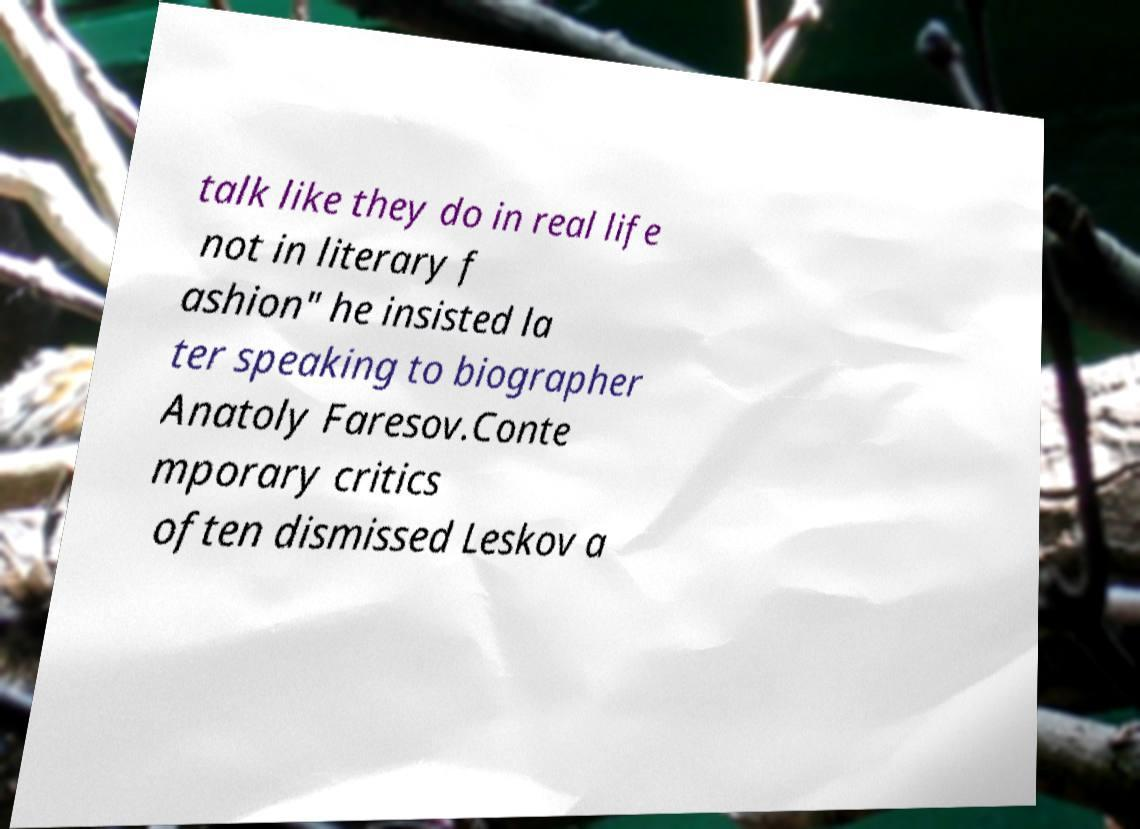Please read and relay the text visible in this image. What does it say? talk like they do in real life not in literary f ashion" he insisted la ter speaking to biographer Anatoly Faresov.Conte mporary critics often dismissed Leskov a 